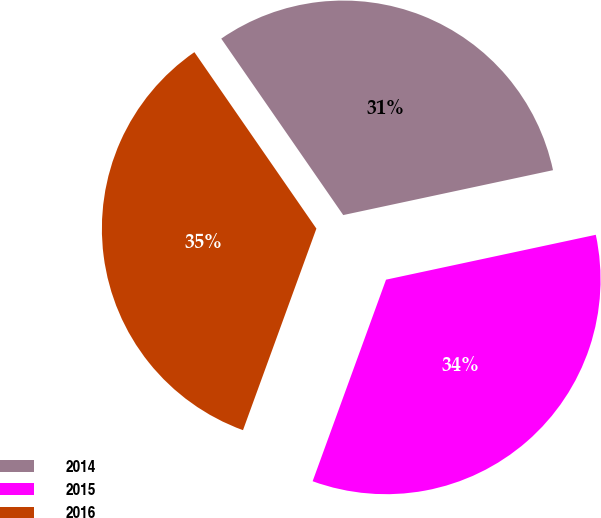Convert chart to OTSL. <chart><loc_0><loc_0><loc_500><loc_500><pie_chart><fcel>2014<fcel>2015<fcel>2016<nl><fcel>31.27%<fcel>33.91%<fcel>34.81%<nl></chart> 